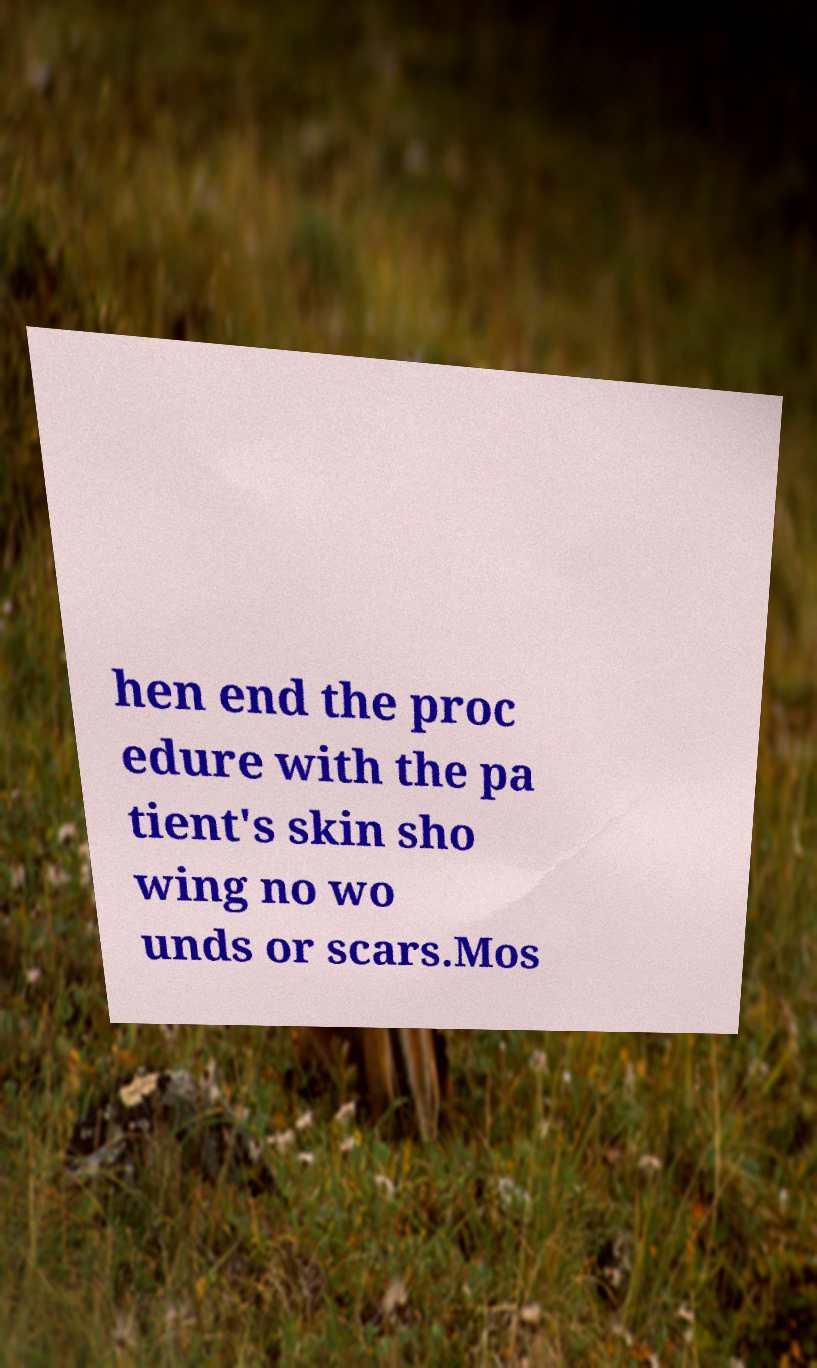For documentation purposes, I need the text within this image transcribed. Could you provide that? hen end the proc edure with the pa tient's skin sho wing no wo unds or scars.Mos 